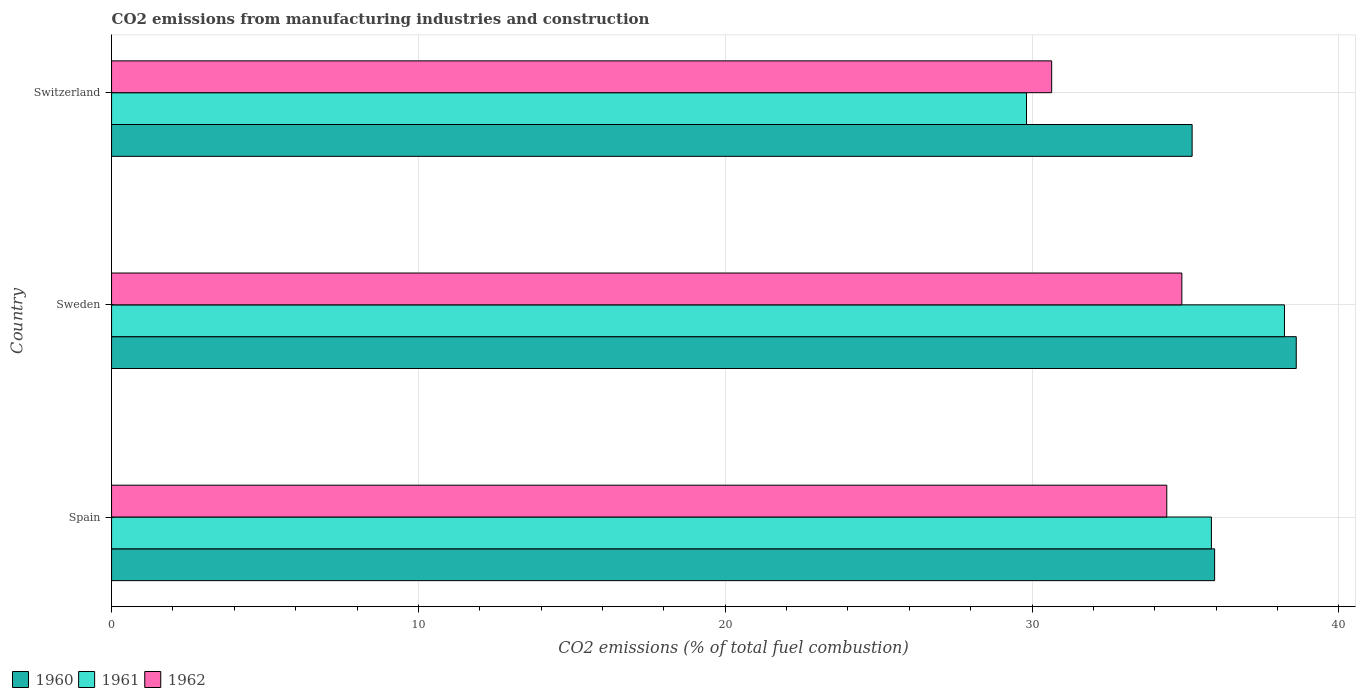How many different coloured bars are there?
Offer a very short reply. 3. Are the number of bars per tick equal to the number of legend labels?
Provide a short and direct response. Yes. How many bars are there on the 2nd tick from the top?
Ensure brevity in your answer.  3. How many bars are there on the 2nd tick from the bottom?
Keep it short and to the point. 3. What is the label of the 3rd group of bars from the top?
Your response must be concise. Spain. What is the amount of CO2 emitted in 1960 in Spain?
Provide a short and direct response. 35.95. Across all countries, what is the maximum amount of CO2 emitted in 1961?
Ensure brevity in your answer.  38.23. Across all countries, what is the minimum amount of CO2 emitted in 1961?
Your answer should be very brief. 29.82. In which country was the amount of CO2 emitted in 1962 maximum?
Ensure brevity in your answer.  Sweden. In which country was the amount of CO2 emitted in 1962 minimum?
Keep it short and to the point. Switzerland. What is the total amount of CO2 emitted in 1961 in the graph?
Your response must be concise. 103.9. What is the difference between the amount of CO2 emitted in 1960 in Sweden and that in Switzerland?
Keep it short and to the point. 3.39. What is the difference between the amount of CO2 emitted in 1960 in Spain and the amount of CO2 emitted in 1962 in Sweden?
Offer a very short reply. 1.07. What is the average amount of CO2 emitted in 1961 per country?
Your response must be concise. 34.63. What is the difference between the amount of CO2 emitted in 1961 and amount of CO2 emitted in 1962 in Spain?
Make the answer very short. 1.45. What is the ratio of the amount of CO2 emitted in 1962 in Spain to that in Sweden?
Keep it short and to the point. 0.99. Is the difference between the amount of CO2 emitted in 1961 in Sweden and Switzerland greater than the difference between the amount of CO2 emitted in 1962 in Sweden and Switzerland?
Keep it short and to the point. Yes. What is the difference between the highest and the second highest amount of CO2 emitted in 1962?
Make the answer very short. 0.49. What is the difference between the highest and the lowest amount of CO2 emitted in 1962?
Ensure brevity in your answer.  4.24. Is the sum of the amount of CO2 emitted in 1961 in Sweden and Switzerland greater than the maximum amount of CO2 emitted in 1962 across all countries?
Offer a terse response. Yes. What does the 3rd bar from the top in Sweden represents?
Give a very brief answer. 1960. How many bars are there?
Your answer should be compact. 9. Are all the bars in the graph horizontal?
Provide a short and direct response. Yes. How many countries are there in the graph?
Your response must be concise. 3. Are the values on the major ticks of X-axis written in scientific E-notation?
Offer a very short reply. No. Where does the legend appear in the graph?
Give a very brief answer. Bottom left. How many legend labels are there?
Provide a short and direct response. 3. How are the legend labels stacked?
Provide a succinct answer. Horizontal. What is the title of the graph?
Keep it short and to the point. CO2 emissions from manufacturing industries and construction. Does "1964" appear as one of the legend labels in the graph?
Your response must be concise. No. What is the label or title of the X-axis?
Keep it short and to the point. CO2 emissions (% of total fuel combustion). What is the CO2 emissions (% of total fuel combustion) of 1960 in Spain?
Provide a short and direct response. 35.95. What is the CO2 emissions (% of total fuel combustion) in 1961 in Spain?
Offer a very short reply. 35.85. What is the CO2 emissions (% of total fuel combustion) in 1962 in Spain?
Make the answer very short. 34.39. What is the CO2 emissions (% of total fuel combustion) of 1960 in Sweden?
Provide a succinct answer. 38.61. What is the CO2 emissions (% of total fuel combustion) of 1961 in Sweden?
Provide a succinct answer. 38.23. What is the CO2 emissions (% of total fuel combustion) of 1962 in Sweden?
Offer a terse response. 34.88. What is the CO2 emissions (% of total fuel combustion) in 1960 in Switzerland?
Ensure brevity in your answer.  35.22. What is the CO2 emissions (% of total fuel combustion) in 1961 in Switzerland?
Your answer should be compact. 29.82. What is the CO2 emissions (% of total fuel combustion) of 1962 in Switzerland?
Provide a succinct answer. 30.64. Across all countries, what is the maximum CO2 emissions (% of total fuel combustion) of 1960?
Make the answer very short. 38.61. Across all countries, what is the maximum CO2 emissions (% of total fuel combustion) of 1961?
Offer a very short reply. 38.23. Across all countries, what is the maximum CO2 emissions (% of total fuel combustion) of 1962?
Ensure brevity in your answer.  34.88. Across all countries, what is the minimum CO2 emissions (% of total fuel combustion) of 1960?
Your answer should be very brief. 35.22. Across all countries, what is the minimum CO2 emissions (% of total fuel combustion) of 1961?
Your response must be concise. 29.82. Across all countries, what is the minimum CO2 emissions (% of total fuel combustion) of 1962?
Your answer should be very brief. 30.64. What is the total CO2 emissions (% of total fuel combustion) in 1960 in the graph?
Give a very brief answer. 109.78. What is the total CO2 emissions (% of total fuel combustion) in 1961 in the graph?
Provide a succinct answer. 103.9. What is the total CO2 emissions (% of total fuel combustion) in 1962 in the graph?
Offer a terse response. 99.92. What is the difference between the CO2 emissions (% of total fuel combustion) of 1960 in Spain and that in Sweden?
Keep it short and to the point. -2.66. What is the difference between the CO2 emissions (% of total fuel combustion) of 1961 in Spain and that in Sweden?
Keep it short and to the point. -2.38. What is the difference between the CO2 emissions (% of total fuel combustion) of 1962 in Spain and that in Sweden?
Ensure brevity in your answer.  -0.49. What is the difference between the CO2 emissions (% of total fuel combustion) in 1960 in Spain and that in Switzerland?
Provide a short and direct response. 0.73. What is the difference between the CO2 emissions (% of total fuel combustion) of 1961 in Spain and that in Switzerland?
Your answer should be compact. 6.03. What is the difference between the CO2 emissions (% of total fuel combustion) of 1962 in Spain and that in Switzerland?
Your answer should be compact. 3.75. What is the difference between the CO2 emissions (% of total fuel combustion) in 1960 in Sweden and that in Switzerland?
Offer a terse response. 3.39. What is the difference between the CO2 emissions (% of total fuel combustion) in 1961 in Sweden and that in Switzerland?
Your answer should be compact. 8.41. What is the difference between the CO2 emissions (% of total fuel combustion) of 1962 in Sweden and that in Switzerland?
Provide a short and direct response. 4.24. What is the difference between the CO2 emissions (% of total fuel combustion) in 1960 in Spain and the CO2 emissions (% of total fuel combustion) in 1961 in Sweden?
Make the answer very short. -2.28. What is the difference between the CO2 emissions (% of total fuel combustion) of 1960 in Spain and the CO2 emissions (% of total fuel combustion) of 1962 in Sweden?
Your answer should be compact. 1.07. What is the difference between the CO2 emissions (% of total fuel combustion) in 1961 in Spain and the CO2 emissions (% of total fuel combustion) in 1962 in Sweden?
Give a very brief answer. 0.96. What is the difference between the CO2 emissions (% of total fuel combustion) of 1960 in Spain and the CO2 emissions (% of total fuel combustion) of 1961 in Switzerland?
Your answer should be compact. 6.13. What is the difference between the CO2 emissions (% of total fuel combustion) of 1960 in Spain and the CO2 emissions (% of total fuel combustion) of 1962 in Switzerland?
Offer a very short reply. 5.31. What is the difference between the CO2 emissions (% of total fuel combustion) in 1961 in Spain and the CO2 emissions (% of total fuel combustion) in 1962 in Switzerland?
Your answer should be compact. 5.21. What is the difference between the CO2 emissions (% of total fuel combustion) in 1960 in Sweden and the CO2 emissions (% of total fuel combustion) in 1961 in Switzerland?
Provide a succinct answer. 8.79. What is the difference between the CO2 emissions (% of total fuel combustion) of 1960 in Sweden and the CO2 emissions (% of total fuel combustion) of 1962 in Switzerland?
Your response must be concise. 7.97. What is the difference between the CO2 emissions (% of total fuel combustion) in 1961 in Sweden and the CO2 emissions (% of total fuel combustion) in 1962 in Switzerland?
Ensure brevity in your answer.  7.59. What is the average CO2 emissions (% of total fuel combustion) of 1960 per country?
Provide a short and direct response. 36.59. What is the average CO2 emissions (% of total fuel combustion) of 1961 per country?
Provide a succinct answer. 34.63. What is the average CO2 emissions (% of total fuel combustion) of 1962 per country?
Keep it short and to the point. 33.31. What is the difference between the CO2 emissions (% of total fuel combustion) of 1960 and CO2 emissions (% of total fuel combustion) of 1961 in Spain?
Your answer should be very brief. 0.1. What is the difference between the CO2 emissions (% of total fuel combustion) in 1960 and CO2 emissions (% of total fuel combustion) in 1962 in Spain?
Your answer should be very brief. 1.56. What is the difference between the CO2 emissions (% of total fuel combustion) in 1961 and CO2 emissions (% of total fuel combustion) in 1962 in Spain?
Make the answer very short. 1.45. What is the difference between the CO2 emissions (% of total fuel combustion) in 1960 and CO2 emissions (% of total fuel combustion) in 1961 in Sweden?
Keep it short and to the point. 0.38. What is the difference between the CO2 emissions (% of total fuel combustion) of 1960 and CO2 emissions (% of total fuel combustion) of 1962 in Sweden?
Your answer should be very brief. 3.73. What is the difference between the CO2 emissions (% of total fuel combustion) in 1961 and CO2 emissions (% of total fuel combustion) in 1962 in Sweden?
Provide a short and direct response. 3.35. What is the difference between the CO2 emissions (% of total fuel combustion) in 1960 and CO2 emissions (% of total fuel combustion) in 1961 in Switzerland?
Ensure brevity in your answer.  5.4. What is the difference between the CO2 emissions (% of total fuel combustion) in 1960 and CO2 emissions (% of total fuel combustion) in 1962 in Switzerland?
Give a very brief answer. 4.58. What is the difference between the CO2 emissions (% of total fuel combustion) in 1961 and CO2 emissions (% of total fuel combustion) in 1962 in Switzerland?
Give a very brief answer. -0.82. What is the ratio of the CO2 emissions (% of total fuel combustion) of 1960 in Spain to that in Sweden?
Offer a terse response. 0.93. What is the ratio of the CO2 emissions (% of total fuel combustion) in 1961 in Spain to that in Sweden?
Offer a very short reply. 0.94. What is the ratio of the CO2 emissions (% of total fuel combustion) in 1962 in Spain to that in Sweden?
Your answer should be very brief. 0.99. What is the ratio of the CO2 emissions (% of total fuel combustion) of 1960 in Spain to that in Switzerland?
Make the answer very short. 1.02. What is the ratio of the CO2 emissions (% of total fuel combustion) of 1961 in Spain to that in Switzerland?
Give a very brief answer. 1.2. What is the ratio of the CO2 emissions (% of total fuel combustion) of 1962 in Spain to that in Switzerland?
Your answer should be very brief. 1.12. What is the ratio of the CO2 emissions (% of total fuel combustion) in 1960 in Sweden to that in Switzerland?
Give a very brief answer. 1.1. What is the ratio of the CO2 emissions (% of total fuel combustion) of 1961 in Sweden to that in Switzerland?
Your answer should be compact. 1.28. What is the ratio of the CO2 emissions (% of total fuel combustion) in 1962 in Sweden to that in Switzerland?
Provide a succinct answer. 1.14. What is the difference between the highest and the second highest CO2 emissions (% of total fuel combustion) in 1960?
Offer a very short reply. 2.66. What is the difference between the highest and the second highest CO2 emissions (% of total fuel combustion) of 1961?
Your answer should be compact. 2.38. What is the difference between the highest and the second highest CO2 emissions (% of total fuel combustion) in 1962?
Your response must be concise. 0.49. What is the difference between the highest and the lowest CO2 emissions (% of total fuel combustion) of 1960?
Your answer should be compact. 3.39. What is the difference between the highest and the lowest CO2 emissions (% of total fuel combustion) of 1961?
Ensure brevity in your answer.  8.41. What is the difference between the highest and the lowest CO2 emissions (% of total fuel combustion) of 1962?
Make the answer very short. 4.24. 